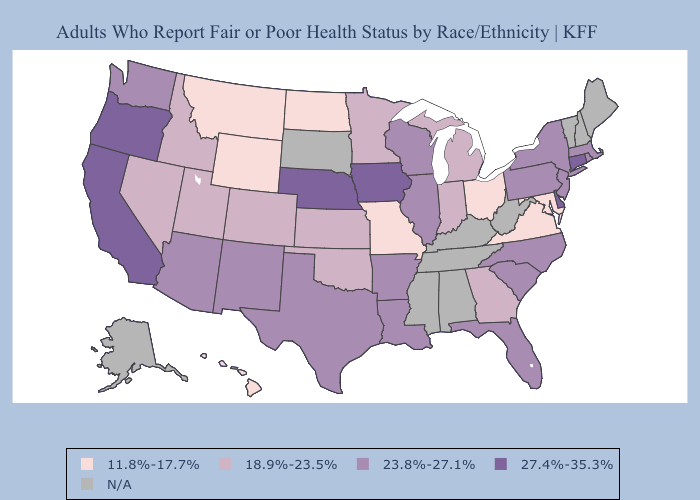Among the states that border Ohio , does Indiana have the highest value?
Keep it brief. No. Does the map have missing data?
Quick response, please. Yes. What is the highest value in the Northeast ?
Quick response, please. 27.4%-35.3%. Does the map have missing data?
Keep it brief. Yes. Does the first symbol in the legend represent the smallest category?
Give a very brief answer. Yes. Which states have the lowest value in the Northeast?
Be succinct. Massachusetts, New Jersey, New York, Pennsylvania, Rhode Island. Does Connecticut have the highest value in the USA?
Concise answer only. Yes. Does the map have missing data?
Short answer required. Yes. Does the map have missing data?
Quick response, please. Yes. Name the states that have a value in the range 27.4%-35.3%?
Short answer required. California, Connecticut, Delaware, Iowa, Nebraska, Oregon. What is the highest value in the USA?
Quick response, please. 27.4%-35.3%. Does Virginia have the lowest value in the South?
Write a very short answer. Yes. Name the states that have a value in the range N/A?
Answer briefly. Alabama, Alaska, Kentucky, Maine, Mississippi, New Hampshire, South Dakota, Tennessee, Vermont, West Virginia. 